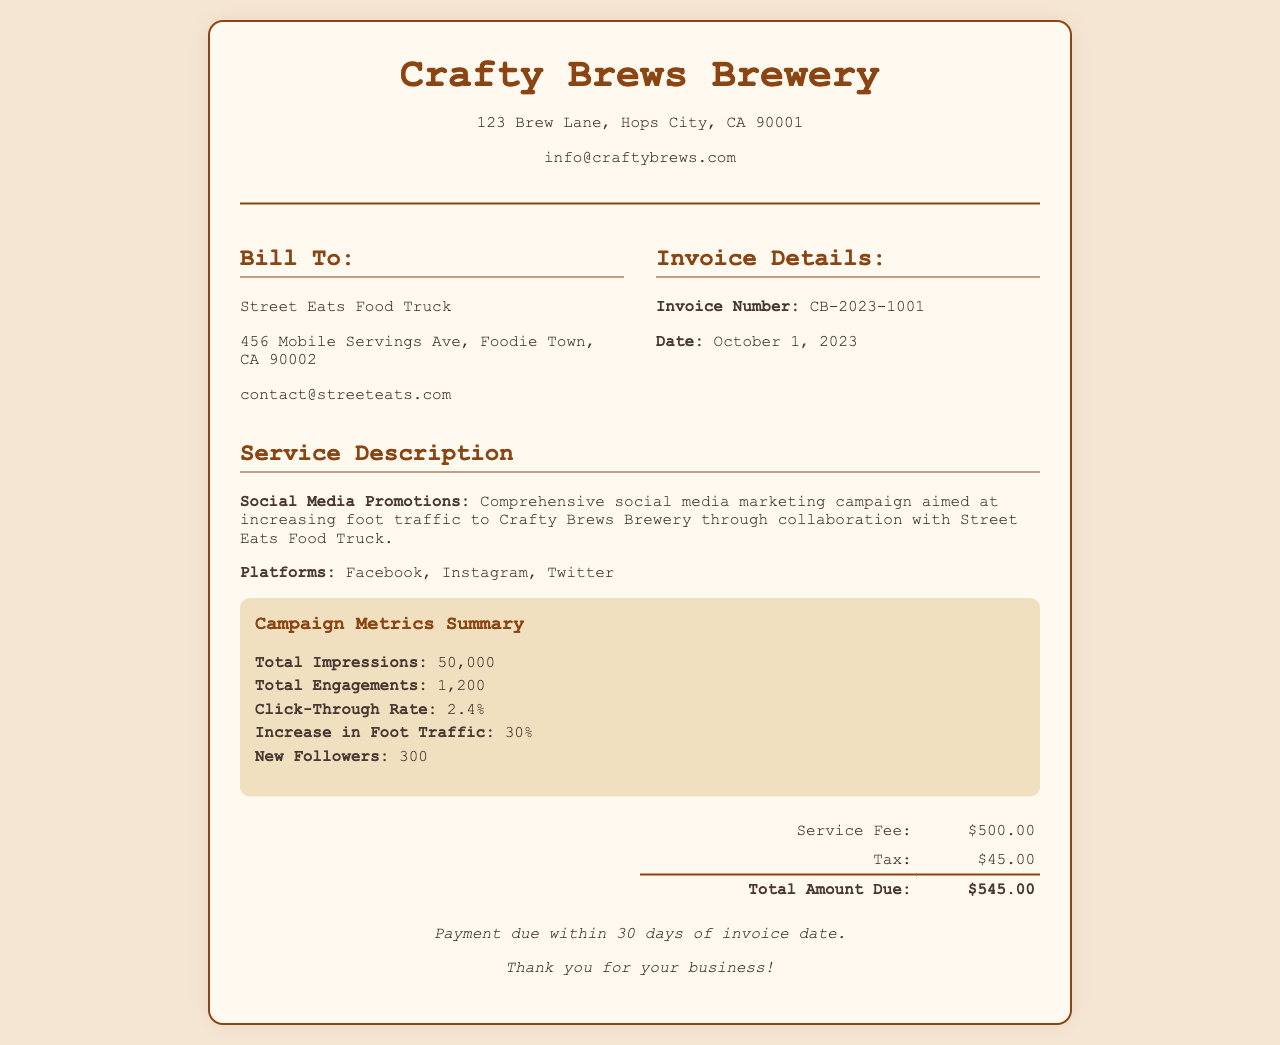What is the invoice number? The invoice number is a specific identifier for this document, found in the invoice details section.
Answer: CB-2023-1001 What is the service fee? The service fee listed on the invoice indicates the cost of the service provided, found in the billing section.
Answer: $500.00 What is the date of the invoice? The date of the invoice is essential for payment terms and can be found in the invoice details section.
Answer: October 1, 2023 How much is the total amount due? The total amount due is the sum of the service fee and tax, found in the billing section.
Answer: $545.00 What platforms were used for the social media promotions? This question refers to the specific platforms mentioned in the service description of the invoice.
Answer: Facebook, Instagram, Twitter What was the increase in foot traffic? This number represents the percentage increase in foot traffic as a result of the social media promotions, located in the metrics section.
Answer: 30% How many total engagements were recorded? Total engagements provide insight into how interactive the campaign was, and can be found in the metrics section.
Answer: 1,200 What is the total number of impressions? The total impressions represent the reach of the social media campaign, stated in the metrics summary.
Answer: 50,000 How many new followers were gained as a result of the campaign? This indicates how many new followers the brewery gained during the promotional campaign, found in the metrics section.
Answer: 300 